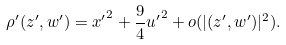Convert formula to latex. <formula><loc_0><loc_0><loc_500><loc_500>\rho ^ { \prime } ( z ^ { \prime } , w ^ { \prime } ) = { x ^ { \prime } } ^ { 2 } + \frac { 9 } { 4 } { u ^ { \prime } } ^ { 2 } + o ( | ( z ^ { \prime } , w ^ { \prime } ) | ^ { 2 } ) .</formula> 